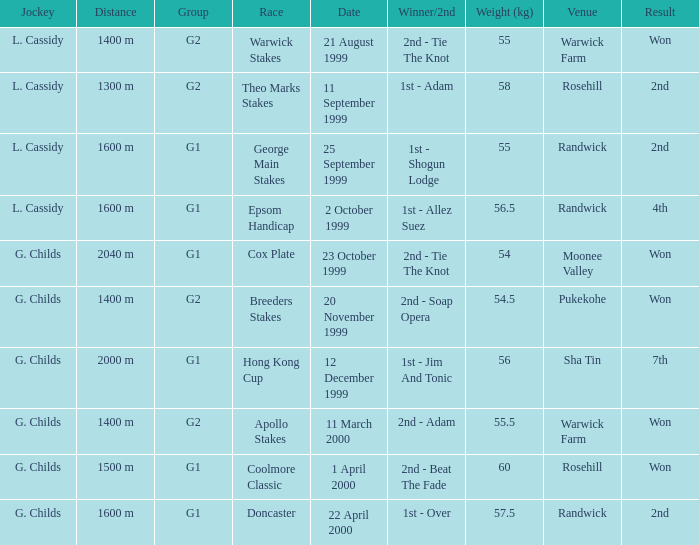List the weight for 56 kilograms. 2000 m. Can you give me this table as a dict? {'header': ['Jockey', 'Distance', 'Group', 'Race', 'Date', 'Winner/2nd', 'Weight (kg)', 'Venue', 'Result'], 'rows': [['L. Cassidy', '1400 m', 'G2', 'Warwick Stakes', '21 August 1999', '2nd - Tie The Knot', '55', 'Warwick Farm', 'Won'], ['L. Cassidy', '1300 m', 'G2', 'Theo Marks Stakes', '11 September 1999', '1st - Adam', '58', 'Rosehill', '2nd'], ['L. Cassidy', '1600 m', 'G1', 'George Main Stakes', '25 September 1999', '1st - Shogun Lodge', '55', 'Randwick', '2nd'], ['L. Cassidy', '1600 m', 'G1', 'Epsom Handicap', '2 October 1999', '1st - Allez Suez', '56.5', 'Randwick', '4th'], ['G. Childs', '2040 m', 'G1', 'Cox Plate', '23 October 1999', '2nd - Tie The Knot', '54', 'Moonee Valley', 'Won'], ['G. Childs', '1400 m', 'G2', 'Breeders Stakes', '20 November 1999', '2nd - Soap Opera', '54.5', 'Pukekohe', 'Won'], ['G. Childs', '2000 m', 'G1', 'Hong Kong Cup', '12 December 1999', '1st - Jim And Tonic', '56', 'Sha Tin', '7th'], ['G. Childs', '1400 m', 'G2', 'Apollo Stakes', '11 March 2000', '2nd - Adam', '55.5', 'Warwick Farm', 'Won'], ['G. Childs', '1500 m', 'G1', 'Coolmore Classic', '1 April 2000', '2nd - Beat The Fade', '60', 'Rosehill', 'Won'], ['G. Childs', '1600 m', 'G1', 'Doncaster', '22 April 2000', '1st - Over', '57.5', 'Randwick', '2nd']]} 